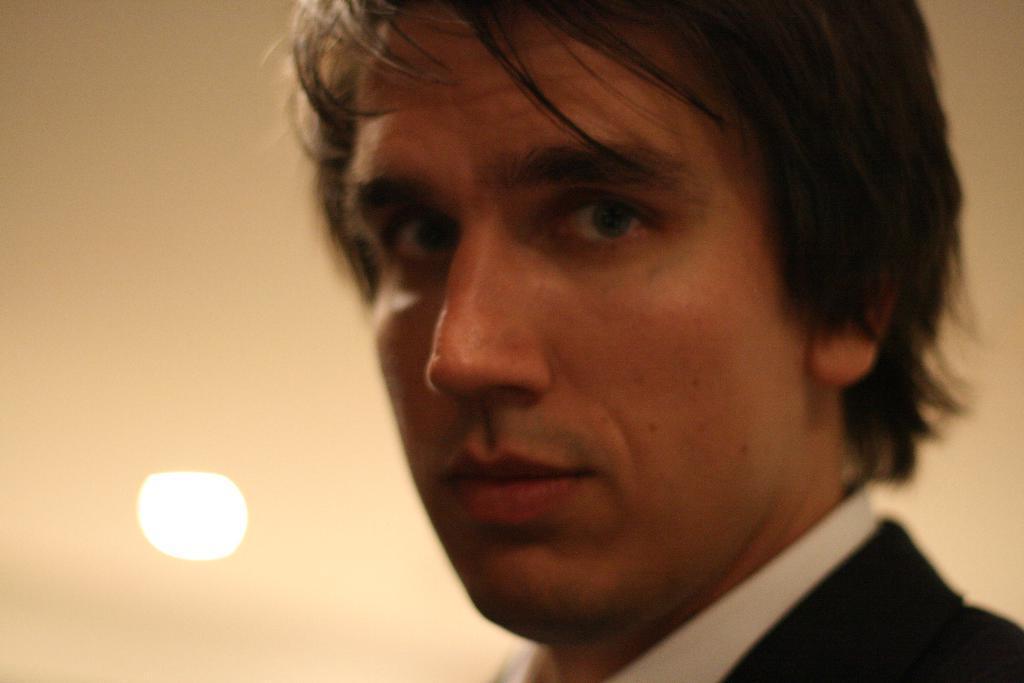Describe this image in one or two sentences. In this image we can see a man. 